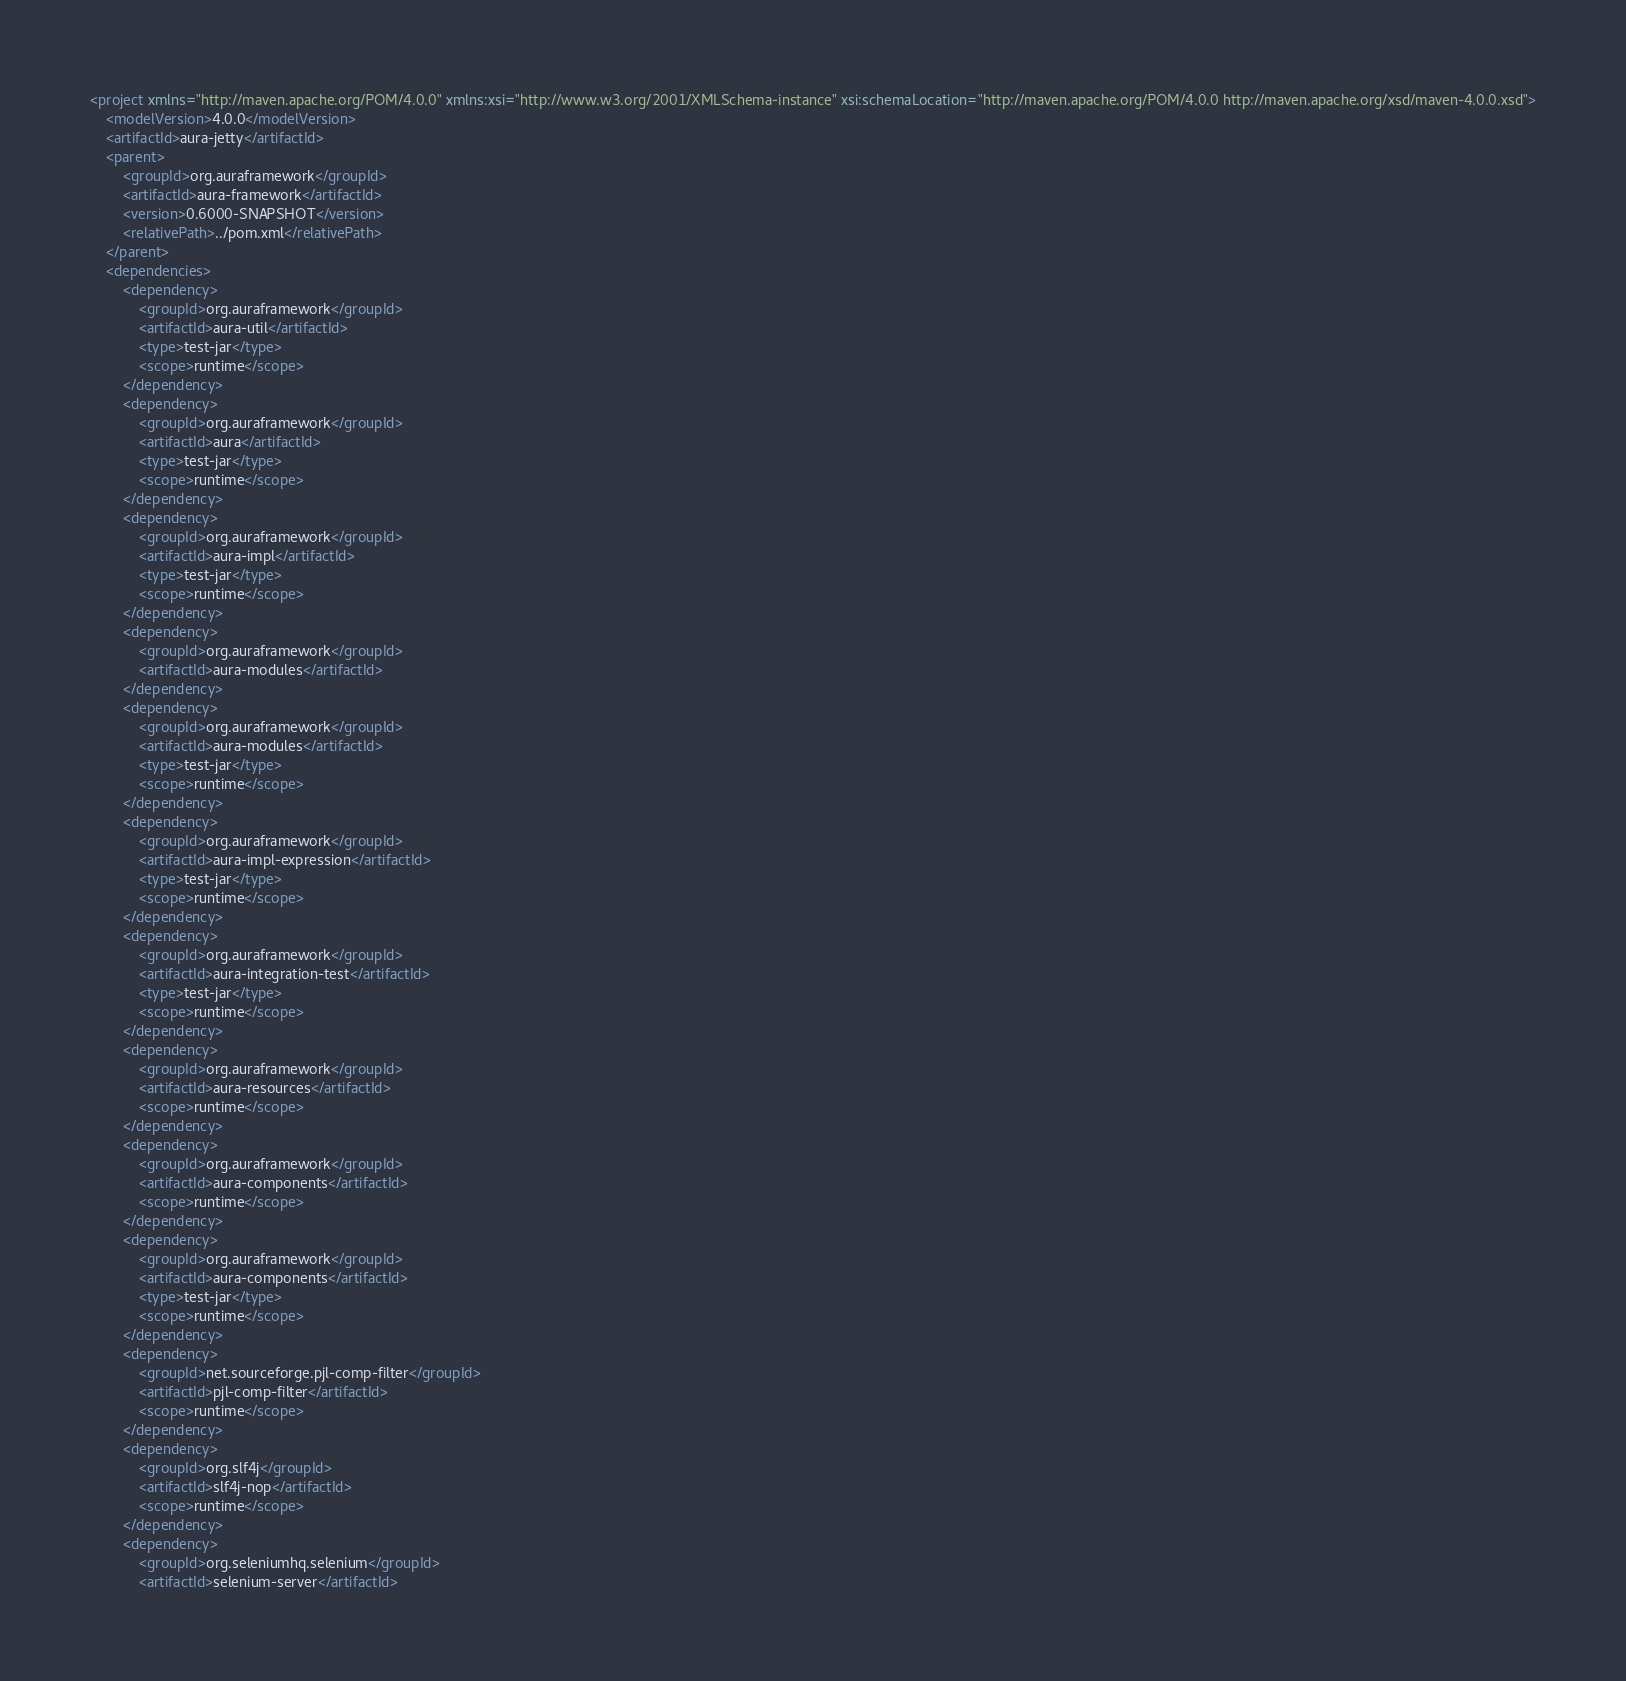Convert code to text. <code><loc_0><loc_0><loc_500><loc_500><_XML_><project xmlns="http://maven.apache.org/POM/4.0.0" xmlns:xsi="http://www.w3.org/2001/XMLSchema-instance" xsi:schemaLocation="http://maven.apache.org/POM/4.0.0 http://maven.apache.org/xsd/maven-4.0.0.xsd">
    <modelVersion>4.0.0</modelVersion>
    <artifactId>aura-jetty</artifactId>
    <parent>
        <groupId>org.auraframework</groupId>
        <artifactId>aura-framework</artifactId>
        <version>0.6000-SNAPSHOT</version>
        <relativePath>../pom.xml</relativePath>
    </parent>
    <dependencies>
        <dependency>
            <groupId>org.auraframework</groupId>
            <artifactId>aura-util</artifactId>
            <type>test-jar</type>
            <scope>runtime</scope>
        </dependency>
        <dependency>
            <groupId>org.auraframework</groupId>
            <artifactId>aura</artifactId>
            <type>test-jar</type>
            <scope>runtime</scope>
        </dependency>
        <dependency>
            <groupId>org.auraframework</groupId>
            <artifactId>aura-impl</artifactId>
            <type>test-jar</type>
            <scope>runtime</scope>
        </dependency>
        <dependency>
            <groupId>org.auraframework</groupId>
            <artifactId>aura-modules</artifactId>
        </dependency>
        <dependency>
            <groupId>org.auraframework</groupId>
            <artifactId>aura-modules</artifactId>
            <type>test-jar</type>
            <scope>runtime</scope>
        </dependency>
        <dependency>
            <groupId>org.auraframework</groupId>
            <artifactId>aura-impl-expression</artifactId>
            <type>test-jar</type>
            <scope>runtime</scope>
        </dependency>
        <dependency>
            <groupId>org.auraframework</groupId>
            <artifactId>aura-integration-test</artifactId>
            <type>test-jar</type>
            <scope>runtime</scope>
        </dependency>
        <dependency>
            <groupId>org.auraframework</groupId>
            <artifactId>aura-resources</artifactId>
            <scope>runtime</scope>
        </dependency>
        <dependency>
            <groupId>org.auraframework</groupId>
            <artifactId>aura-components</artifactId>
            <scope>runtime</scope>
        </dependency>
        <dependency>
            <groupId>org.auraframework</groupId>
            <artifactId>aura-components</artifactId>
            <type>test-jar</type>
            <scope>runtime</scope>
        </dependency>
        <dependency>
            <groupId>net.sourceforge.pjl-comp-filter</groupId>
            <artifactId>pjl-comp-filter</artifactId>
            <scope>runtime</scope>
        </dependency>
        <dependency>
            <groupId>org.slf4j</groupId>
            <artifactId>slf4j-nop</artifactId>
            <scope>runtime</scope>
        </dependency>
        <dependency>
            <groupId>org.seleniumhq.selenium</groupId>
            <artifactId>selenium-server</artifactId></code> 